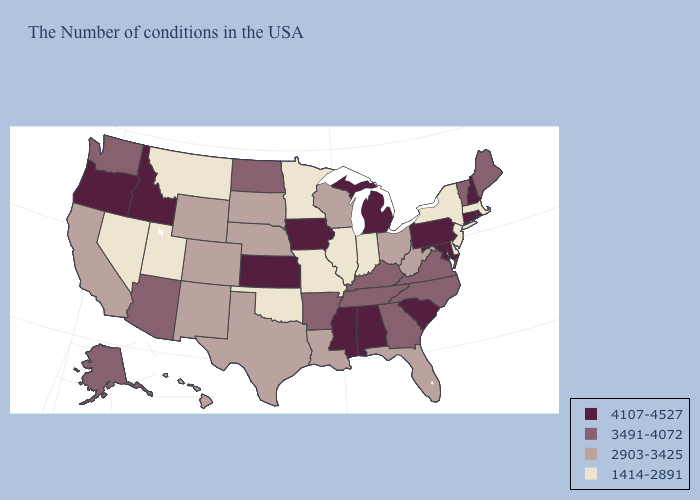Name the states that have a value in the range 1414-2891?
Be succinct. Massachusetts, New York, New Jersey, Delaware, Indiana, Illinois, Missouri, Minnesota, Oklahoma, Utah, Montana, Nevada. What is the value of Rhode Island?
Write a very short answer. 4107-4527. Name the states that have a value in the range 3491-4072?
Be succinct. Maine, Vermont, Virginia, North Carolina, Georgia, Kentucky, Tennessee, Arkansas, North Dakota, Arizona, Washington, Alaska. Name the states that have a value in the range 3491-4072?
Be succinct. Maine, Vermont, Virginia, North Carolina, Georgia, Kentucky, Tennessee, Arkansas, North Dakota, Arizona, Washington, Alaska. What is the value of West Virginia?
Give a very brief answer. 2903-3425. Name the states that have a value in the range 1414-2891?
Answer briefly. Massachusetts, New York, New Jersey, Delaware, Indiana, Illinois, Missouri, Minnesota, Oklahoma, Utah, Montana, Nevada. What is the value of Vermont?
Give a very brief answer. 3491-4072. What is the value of Nebraska?
Give a very brief answer. 2903-3425. Does the map have missing data?
Answer briefly. No. Which states have the lowest value in the USA?
Concise answer only. Massachusetts, New York, New Jersey, Delaware, Indiana, Illinois, Missouri, Minnesota, Oklahoma, Utah, Montana, Nevada. Name the states that have a value in the range 4107-4527?
Answer briefly. Rhode Island, New Hampshire, Connecticut, Maryland, Pennsylvania, South Carolina, Michigan, Alabama, Mississippi, Iowa, Kansas, Idaho, Oregon. What is the lowest value in the USA?
Be succinct. 1414-2891. Name the states that have a value in the range 3491-4072?
Be succinct. Maine, Vermont, Virginia, North Carolina, Georgia, Kentucky, Tennessee, Arkansas, North Dakota, Arizona, Washington, Alaska. What is the value of South Carolina?
Keep it brief. 4107-4527. 